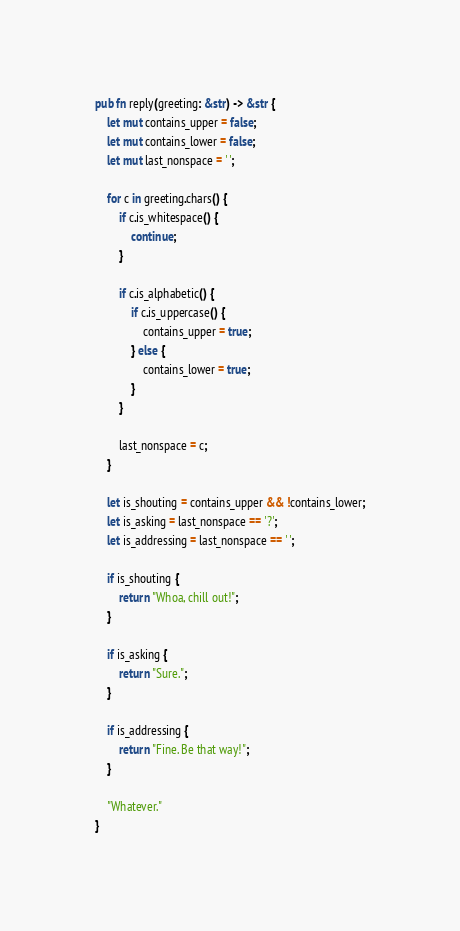Convert code to text. <code><loc_0><loc_0><loc_500><loc_500><_Rust_>pub fn reply(greeting: &str) -> &str {
    let mut contains_upper = false;
    let mut contains_lower = false;
    let mut last_nonspace = ' ';

    for c in greeting.chars() {
        if c.is_whitespace() {
            continue;
        }

        if c.is_alphabetic() {
            if c.is_uppercase() {
                contains_upper = true;
            } else {
                contains_lower = true;
            }
        }

        last_nonspace = c;
    }

    let is_shouting = contains_upper && !contains_lower;
    let is_asking = last_nonspace == '?';
    let is_addressing = last_nonspace == ' ';

    if is_shouting {
        return "Whoa, chill out!";
    }

    if is_asking {
        return "Sure.";
    }

    if is_addressing {
        return "Fine. Be that way!";
    }

    "Whatever."
}
</code> 